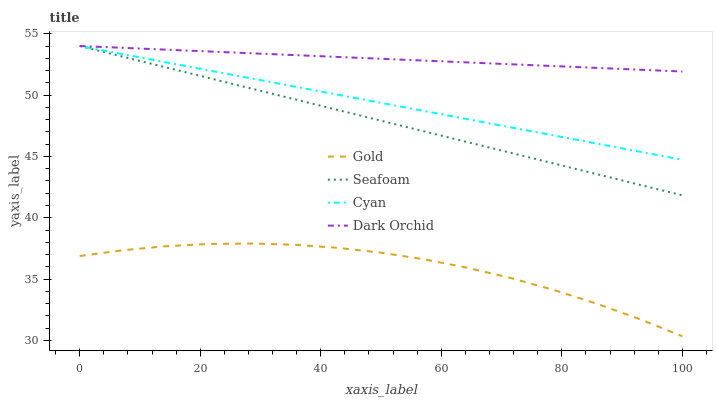Does Gold have the minimum area under the curve?
Answer yes or no. Yes. Does Dark Orchid have the maximum area under the curve?
Answer yes or no. Yes. Does Cyan have the minimum area under the curve?
Answer yes or no. No. Does Cyan have the maximum area under the curve?
Answer yes or no. No. Is Dark Orchid the smoothest?
Answer yes or no. Yes. Is Gold the roughest?
Answer yes or no. Yes. Is Cyan the smoothest?
Answer yes or no. No. Is Cyan the roughest?
Answer yes or no. No. Does Gold have the lowest value?
Answer yes or no. Yes. Does Cyan have the lowest value?
Answer yes or no. No. Does Seafoam have the highest value?
Answer yes or no. Yes. Does Gold have the highest value?
Answer yes or no. No. Is Gold less than Cyan?
Answer yes or no. Yes. Is Cyan greater than Gold?
Answer yes or no. Yes. Does Cyan intersect Dark Orchid?
Answer yes or no. Yes. Is Cyan less than Dark Orchid?
Answer yes or no. No. Is Cyan greater than Dark Orchid?
Answer yes or no. No. Does Gold intersect Cyan?
Answer yes or no. No. 